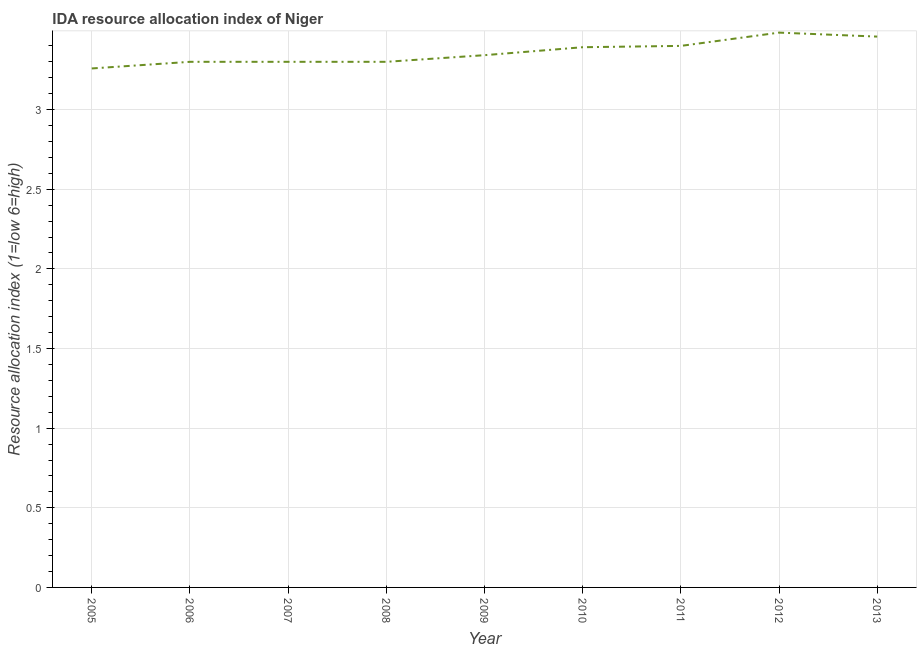Across all years, what is the maximum ida resource allocation index?
Give a very brief answer. 3.48. Across all years, what is the minimum ida resource allocation index?
Make the answer very short. 3.26. In which year was the ida resource allocation index minimum?
Provide a short and direct response. 2005. What is the sum of the ida resource allocation index?
Your response must be concise. 30.23. What is the difference between the ida resource allocation index in 2006 and 2013?
Offer a very short reply. -0.16. What is the average ida resource allocation index per year?
Provide a short and direct response. 3.36. What is the median ida resource allocation index?
Keep it short and to the point. 3.34. In how many years, is the ida resource allocation index greater than 2.2 ?
Ensure brevity in your answer.  9. What is the ratio of the ida resource allocation index in 2009 to that in 2010?
Give a very brief answer. 0.99. Is the ida resource allocation index in 2008 less than that in 2011?
Provide a short and direct response. Yes. Is the difference between the ida resource allocation index in 2006 and 2009 greater than the difference between any two years?
Give a very brief answer. No. What is the difference between the highest and the second highest ida resource allocation index?
Offer a very short reply. 0.02. Is the sum of the ida resource allocation index in 2005 and 2011 greater than the maximum ida resource allocation index across all years?
Provide a short and direct response. Yes. What is the difference between the highest and the lowest ida resource allocation index?
Ensure brevity in your answer.  0.22. Does the ida resource allocation index monotonically increase over the years?
Keep it short and to the point. No. What is the difference between two consecutive major ticks on the Y-axis?
Offer a very short reply. 0.5. Does the graph contain any zero values?
Provide a succinct answer. No. Does the graph contain grids?
Your response must be concise. Yes. What is the title of the graph?
Make the answer very short. IDA resource allocation index of Niger. What is the label or title of the X-axis?
Ensure brevity in your answer.  Year. What is the label or title of the Y-axis?
Ensure brevity in your answer.  Resource allocation index (1=low 6=high). What is the Resource allocation index (1=low 6=high) in 2005?
Your answer should be compact. 3.26. What is the Resource allocation index (1=low 6=high) of 2007?
Your answer should be compact. 3.3. What is the Resource allocation index (1=low 6=high) in 2008?
Provide a short and direct response. 3.3. What is the Resource allocation index (1=low 6=high) of 2009?
Provide a succinct answer. 3.34. What is the Resource allocation index (1=low 6=high) in 2010?
Ensure brevity in your answer.  3.39. What is the Resource allocation index (1=low 6=high) in 2012?
Offer a very short reply. 3.48. What is the Resource allocation index (1=low 6=high) of 2013?
Your answer should be compact. 3.46. What is the difference between the Resource allocation index (1=low 6=high) in 2005 and 2006?
Give a very brief answer. -0.04. What is the difference between the Resource allocation index (1=low 6=high) in 2005 and 2007?
Give a very brief answer. -0.04. What is the difference between the Resource allocation index (1=low 6=high) in 2005 and 2008?
Your answer should be very brief. -0.04. What is the difference between the Resource allocation index (1=low 6=high) in 2005 and 2009?
Make the answer very short. -0.08. What is the difference between the Resource allocation index (1=low 6=high) in 2005 and 2010?
Offer a terse response. -0.13. What is the difference between the Resource allocation index (1=low 6=high) in 2005 and 2011?
Your answer should be compact. -0.14. What is the difference between the Resource allocation index (1=low 6=high) in 2005 and 2012?
Keep it short and to the point. -0.23. What is the difference between the Resource allocation index (1=low 6=high) in 2005 and 2013?
Your answer should be very brief. -0.2. What is the difference between the Resource allocation index (1=low 6=high) in 2006 and 2009?
Offer a terse response. -0.04. What is the difference between the Resource allocation index (1=low 6=high) in 2006 and 2010?
Provide a short and direct response. -0.09. What is the difference between the Resource allocation index (1=low 6=high) in 2006 and 2011?
Keep it short and to the point. -0.1. What is the difference between the Resource allocation index (1=low 6=high) in 2006 and 2012?
Your answer should be very brief. -0.18. What is the difference between the Resource allocation index (1=low 6=high) in 2006 and 2013?
Keep it short and to the point. -0.16. What is the difference between the Resource allocation index (1=low 6=high) in 2007 and 2009?
Your answer should be compact. -0.04. What is the difference between the Resource allocation index (1=low 6=high) in 2007 and 2010?
Your answer should be very brief. -0.09. What is the difference between the Resource allocation index (1=low 6=high) in 2007 and 2011?
Provide a succinct answer. -0.1. What is the difference between the Resource allocation index (1=low 6=high) in 2007 and 2012?
Your answer should be compact. -0.18. What is the difference between the Resource allocation index (1=low 6=high) in 2007 and 2013?
Your answer should be compact. -0.16. What is the difference between the Resource allocation index (1=low 6=high) in 2008 and 2009?
Ensure brevity in your answer.  -0.04. What is the difference between the Resource allocation index (1=low 6=high) in 2008 and 2010?
Offer a terse response. -0.09. What is the difference between the Resource allocation index (1=low 6=high) in 2008 and 2012?
Your answer should be very brief. -0.18. What is the difference between the Resource allocation index (1=low 6=high) in 2008 and 2013?
Your response must be concise. -0.16. What is the difference between the Resource allocation index (1=low 6=high) in 2009 and 2010?
Offer a terse response. -0.05. What is the difference between the Resource allocation index (1=low 6=high) in 2009 and 2011?
Your response must be concise. -0.06. What is the difference between the Resource allocation index (1=low 6=high) in 2009 and 2012?
Give a very brief answer. -0.14. What is the difference between the Resource allocation index (1=low 6=high) in 2009 and 2013?
Make the answer very short. -0.12. What is the difference between the Resource allocation index (1=low 6=high) in 2010 and 2011?
Give a very brief answer. -0.01. What is the difference between the Resource allocation index (1=low 6=high) in 2010 and 2012?
Provide a short and direct response. -0.09. What is the difference between the Resource allocation index (1=low 6=high) in 2010 and 2013?
Provide a succinct answer. -0.07. What is the difference between the Resource allocation index (1=low 6=high) in 2011 and 2012?
Provide a short and direct response. -0.08. What is the difference between the Resource allocation index (1=low 6=high) in 2011 and 2013?
Provide a succinct answer. -0.06. What is the difference between the Resource allocation index (1=low 6=high) in 2012 and 2013?
Your answer should be very brief. 0.03. What is the ratio of the Resource allocation index (1=low 6=high) in 2005 to that in 2006?
Make the answer very short. 0.99. What is the ratio of the Resource allocation index (1=low 6=high) in 2005 to that in 2007?
Give a very brief answer. 0.99. What is the ratio of the Resource allocation index (1=low 6=high) in 2005 to that in 2011?
Offer a very short reply. 0.96. What is the ratio of the Resource allocation index (1=low 6=high) in 2005 to that in 2012?
Ensure brevity in your answer.  0.94. What is the ratio of the Resource allocation index (1=low 6=high) in 2005 to that in 2013?
Offer a terse response. 0.94. What is the ratio of the Resource allocation index (1=low 6=high) in 2006 to that in 2008?
Keep it short and to the point. 1. What is the ratio of the Resource allocation index (1=low 6=high) in 2006 to that in 2009?
Your response must be concise. 0.99. What is the ratio of the Resource allocation index (1=low 6=high) in 2006 to that in 2010?
Keep it short and to the point. 0.97. What is the ratio of the Resource allocation index (1=low 6=high) in 2006 to that in 2012?
Your response must be concise. 0.95. What is the ratio of the Resource allocation index (1=low 6=high) in 2006 to that in 2013?
Provide a short and direct response. 0.95. What is the ratio of the Resource allocation index (1=low 6=high) in 2007 to that in 2009?
Offer a very short reply. 0.99. What is the ratio of the Resource allocation index (1=low 6=high) in 2007 to that in 2010?
Ensure brevity in your answer.  0.97. What is the ratio of the Resource allocation index (1=low 6=high) in 2007 to that in 2012?
Offer a terse response. 0.95. What is the ratio of the Resource allocation index (1=low 6=high) in 2007 to that in 2013?
Offer a very short reply. 0.95. What is the ratio of the Resource allocation index (1=low 6=high) in 2008 to that in 2009?
Your answer should be very brief. 0.99. What is the ratio of the Resource allocation index (1=low 6=high) in 2008 to that in 2012?
Offer a terse response. 0.95. What is the ratio of the Resource allocation index (1=low 6=high) in 2008 to that in 2013?
Provide a short and direct response. 0.95. What is the ratio of the Resource allocation index (1=low 6=high) in 2009 to that in 2010?
Keep it short and to the point. 0.98. What is the ratio of the Resource allocation index (1=low 6=high) in 2009 to that in 2011?
Offer a terse response. 0.98. What is the ratio of the Resource allocation index (1=low 6=high) in 2009 to that in 2012?
Offer a terse response. 0.96. What is the ratio of the Resource allocation index (1=low 6=high) in 2009 to that in 2013?
Offer a terse response. 0.97. What is the ratio of the Resource allocation index (1=low 6=high) in 2010 to that in 2011?
Make the answer very short. 1. What is the ratio of the Resource allocation index (1=low 6=high) in 2010 to that in 2013?
Give a very brief answer. 0.98. What is the ratio of the Resource allocation index (1=low 6=high) in 2011 to that in 2012?
Ensure brevity in your answer.  0.98. What is the ratio of the Resource allocation index (1=low 6=high) in 2011 to that in 2013?
Make the answer very short. 0.98. What is the ratio of the Resource allocation index (1=low 6=high) in 2012 to that in 2013?
Give a very brief answer. 1.01. 